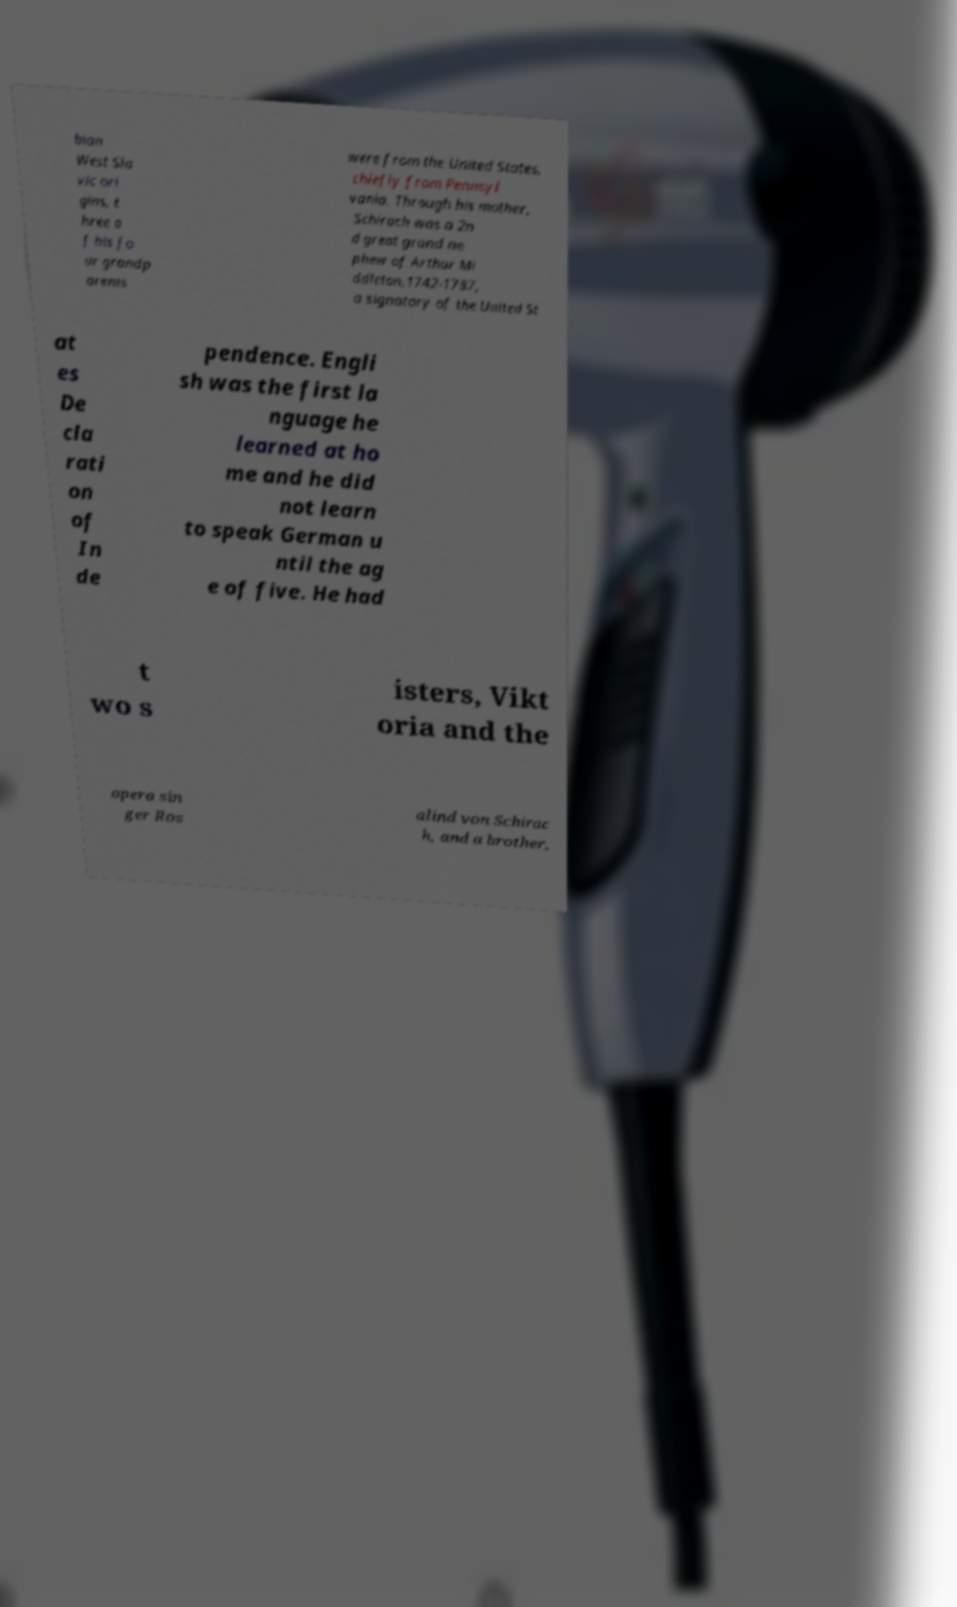Please read and relay the text visible in this image. What does it say? bian West Sla vic ori gins, t hree o f his fo ur grandp arents were from the United States, chiefly from Pennsyl vania. Through his mother, Schirach was a 2n d great grand ne phew of Arthur Mi ddleton,1742-1787, a signatory of the United St at es De cla rati on of In de pendence. Engli sh was the first la nguage he learned at ho me and he did not learn to speak German u ntil the ag e of five. He had t wo s isters, Vikt oria and the opera sin ger Ros alind von Schirac h, and a brother, 